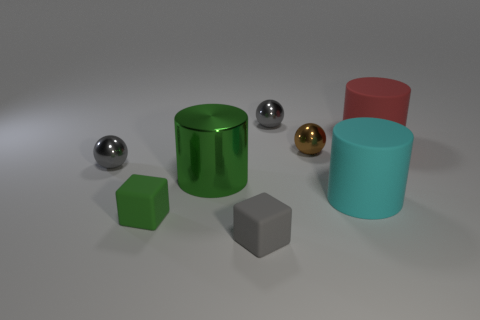What is the size of the brown sphere that is made of the same material as the green cylinder?
Offer a very short reply. Small. There is a gray thing behind the big red rubber thing; does it have the same shape as the big green metallic object?
Offer a very short reply. No. What number of cyan objects are either big matte things or tiny blocks?
Make the answer very short. 1. Are there more yellow things than tiny objects?
Keep it short and to the point. No. The rubber cylinder that is the same size as the cyan matte thing is what color?
Offer a terse response. Red. How many cylinders are either blue metal objects or shiny objects?
Your answer should be compact. 1. Is the shape of the tiny brown object the same as the big rubber thing to the left of the red matte thing?
Keep it short and to the point. No. How many green rubber blocks are the same size as the green cylinder?
Give a very brief answer. 0. There is a small gray shiny object behind the red rubber cylinder; is its shape the same as the gray object to the left of the big metal thing?
Your response must be concise. Yes. There is a object that is the same color as the big shiny cylinder; what is its shape?
Offer a very short reply. Cube. 